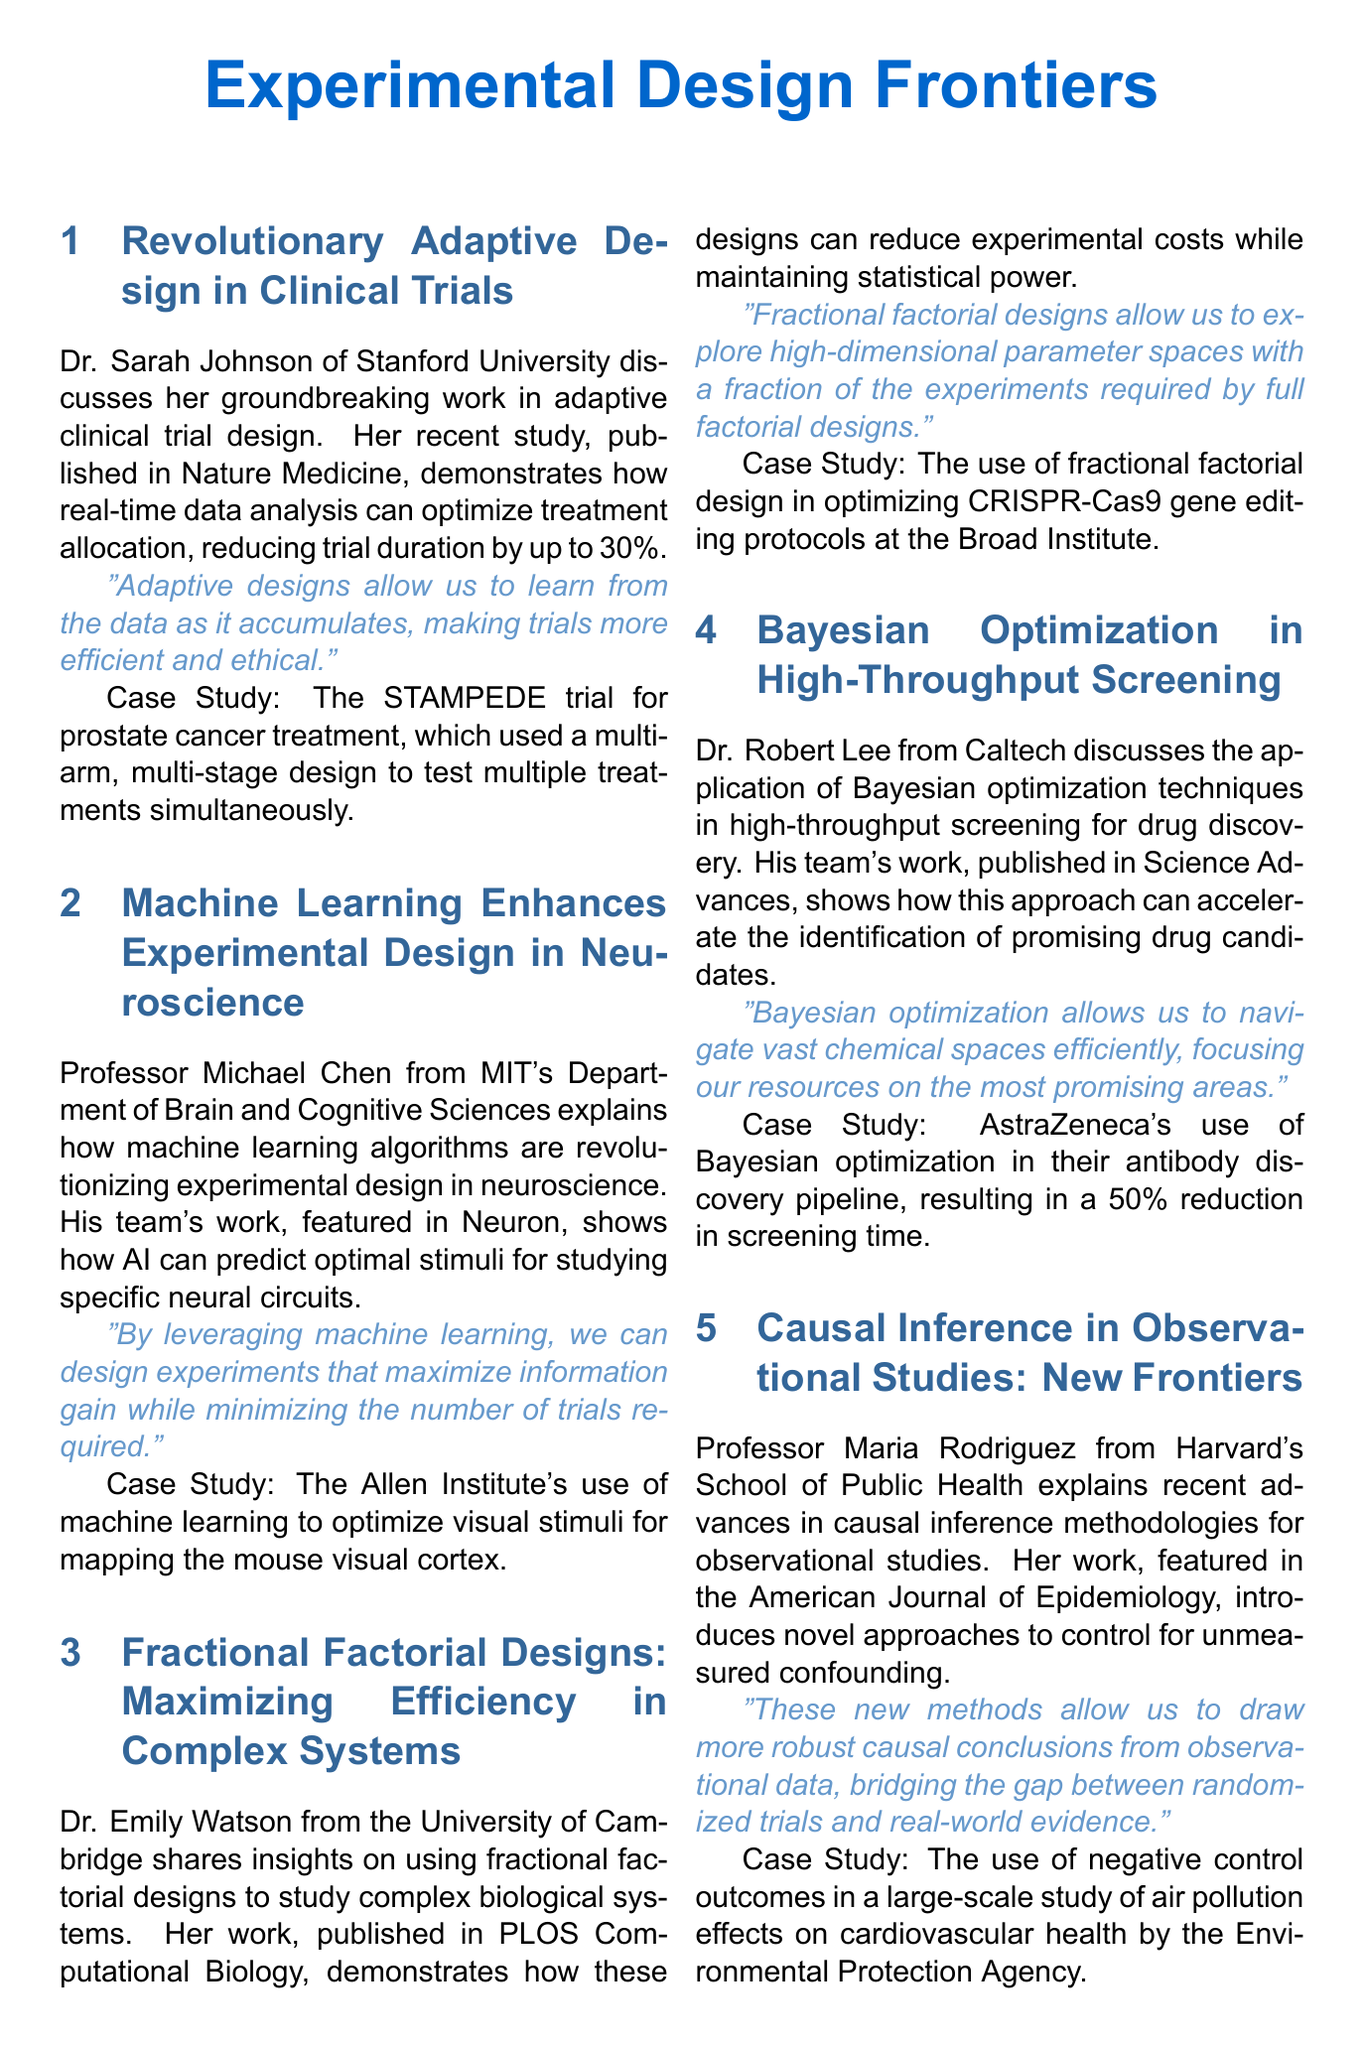What is the title of the newsletter? The title of the newsletter is mentioned at the beginning of the document.
Answer: Experimental Design Frontiers Who is the researcher spotlighted in the newsletter? The document features a section that highlights a specific researcher and their achievements.
Answer: Dr. Alex Thompson What is the date of the upcoming conference ICEDA? Information about the upcoming conferences, including their dates, is provided in the document.
Answer: September 15-17, 2023 What innovative technique did Dr. Sarah Johnson's study focus on? The newsletter discusses various breakthroughs in experimental design methodologies including specific techniques from researchers.
Answer: Adaptive design Which institution is Dr. Emily Watson associated with? Each researcher mentioned in the newsletter is affiliated with a specific institution, which is included in their respective sections.
Answer: University of Cambridge What percentage reduction in trial duration was observed in Dr. Johnson's study? The document outlines the findings and statistics related to the research discussed in the newsletter.
Answer: 30% What is the highlight of the Workshop on Causal Inference and Experimental Design? Information on the highlights of upcoming conferences and workshops is provided.
Answer: Hands-on session on implementing doubly robust estimation methods in R and Python What methodology did Professor Maria Rodriguez focus on? The newsletter discusses different methodologies used by various researchers in their studies.
Answer: Causal inference What does Dr. Robert Lee's team study relate to? The document summarizes the research areas of different scientists and their contributions.
Answer: Drug discovery 